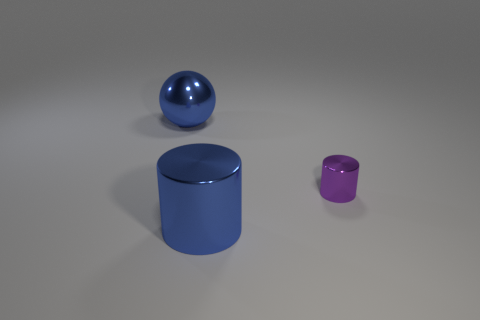There is a object that is both to the left of the small purple cylinder and to the right of the large blue ball; what material is it made of?
Offer a very short reply. Metal. Is there a gray object?
Make the answer very short. No. Does the tiny shiny cylinder have the same color as the large thing in front of the blue shiny ball?
Offer a very short reply. No. What is the material of the cylinder that is the same color as the ball?
Your answer should be compact. Metal. Is there anything else that is the same shape as the small thing?
Your response must be concise. Yes. The big object that is in front of the large metal thing that is to the left of the metal cylinder on the left side of the tiny purple metal thing is what shape?
Make the answer very short. Cylinder. The small metallic thing has what shape?
Offer a terse response. Cylinder. What color is the thing that is in front of the tiny cylinder?
Offer a very short reply. Blue. Is the size of the object in front of the purple thing the same as the blue sphere?
Your answer should be compact. Yes. The other blue object that is the same shape as the small thing is what size?
Your answer should be compact. Large. 